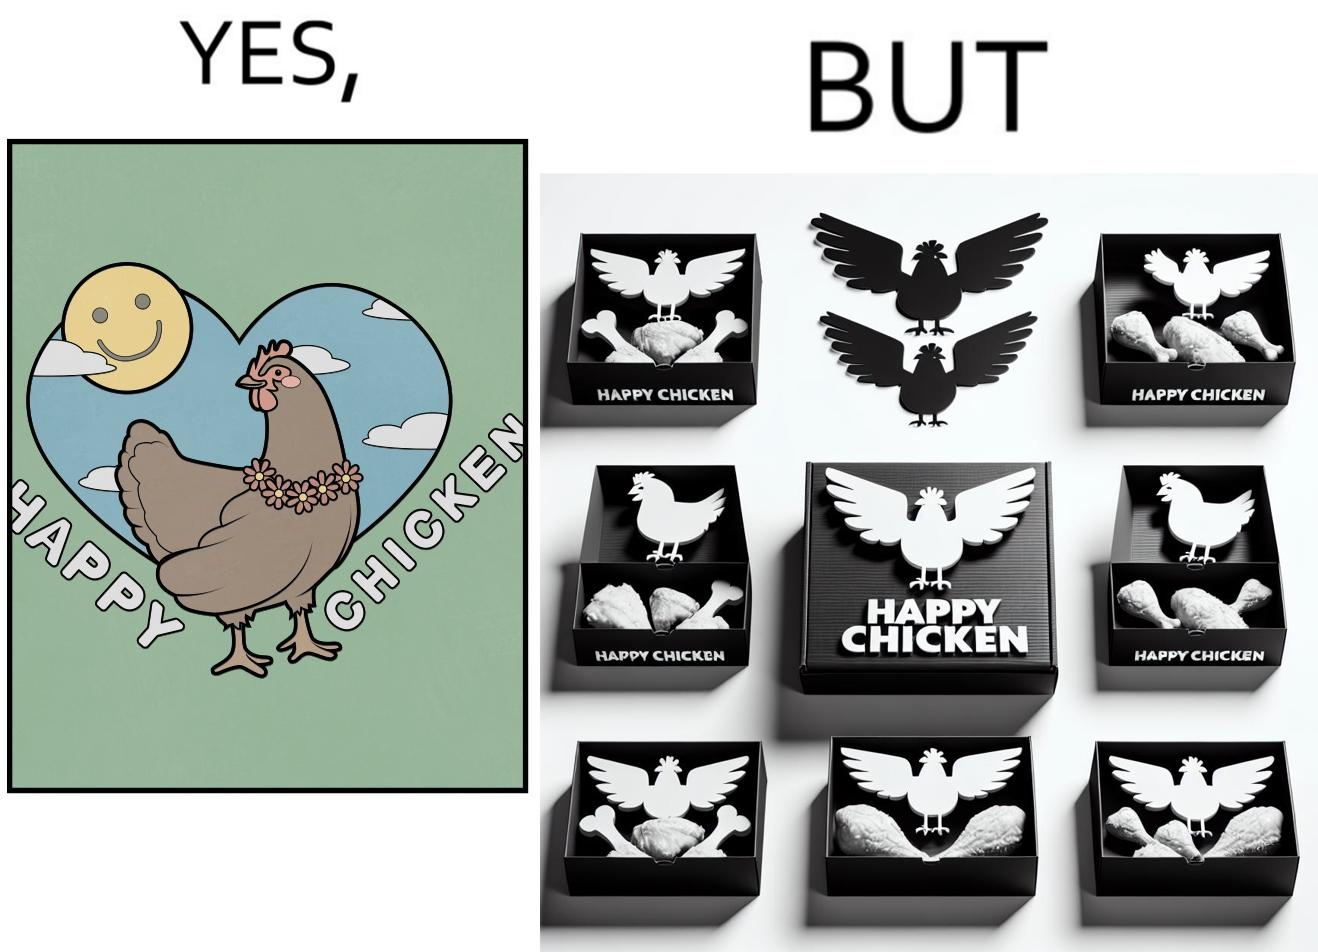What is shown in this image? The image is ironic, because in the left image as in the logo it shows happy chicken but in the right image the chicken pieces are shown packed in boxes 